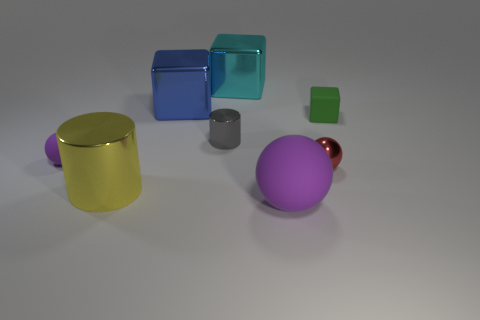Is the number of large blue shiny blocks greater than the number of big red shiny objects?
Your response must be concise. Yes. Is there any other thing of the same color as the large metal cylinder?
Give a very brief answer. No. There is a yellow cylinder that is the same material as the cyan cube; what is its size?
Make the answer very short. Large. What material is the green thing?
Provide a short and direct response. Rubber. How many cyan blocks are the same size as the gray metallic thing?
Make the answer very short. 0. What shape is the small thing that is the same color as the large rubber thing?
Your answer should be very brief. Sphere. Is there a small gray object of the same shape as the green matte thing?
Give a very brief answer. No. The metallic cylinder that is the same size as the blue block is what color?
Offer a very short reply. Yellow. What color is the small rubber object to the left of the big metal object that is in front of the small green rubber object?
Ensure brevity in your answer.  Purple. Does the small matte thing that is in front of the green matte block have the same color as the tiny cube?
Keep it short and to the point. No. 